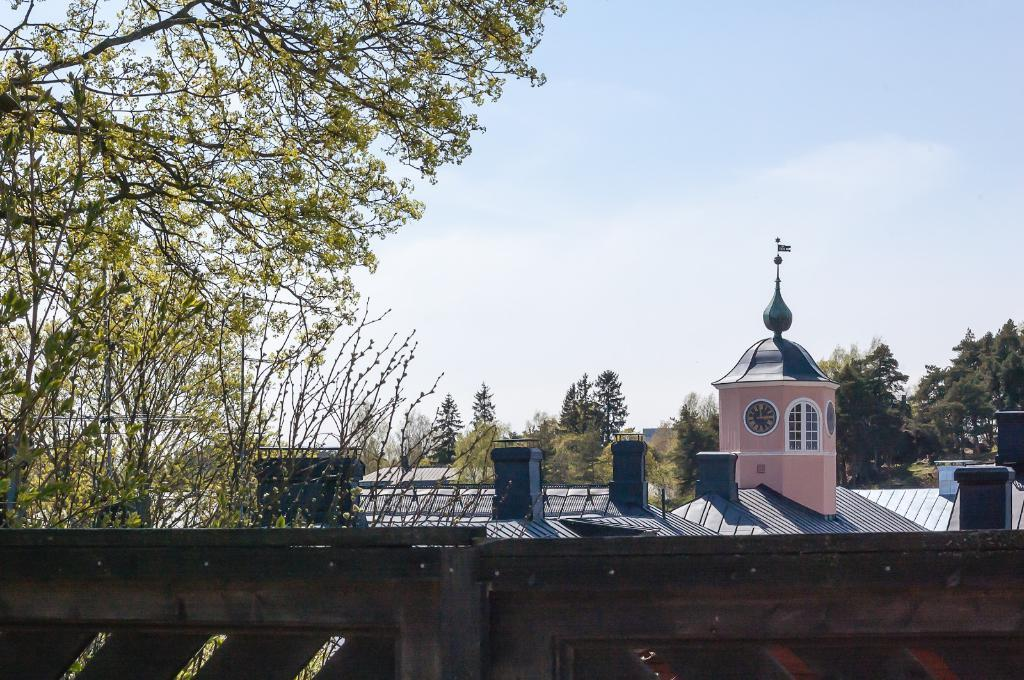What type of structure is visible in the image? The image shows the top roof of buildings. What can be seen behind the buildings? Trees are visible behind the buildings. What is visible at the top of the image? The sky is present at the top of the image. Can you describe any specific features of the trees in the image? A tree branch is present in the image. Is there a carriage moving along the floor in the image? No, there is no carriage or floor present in the image; it shows the top roof of buildings with trees and sky in the background. 